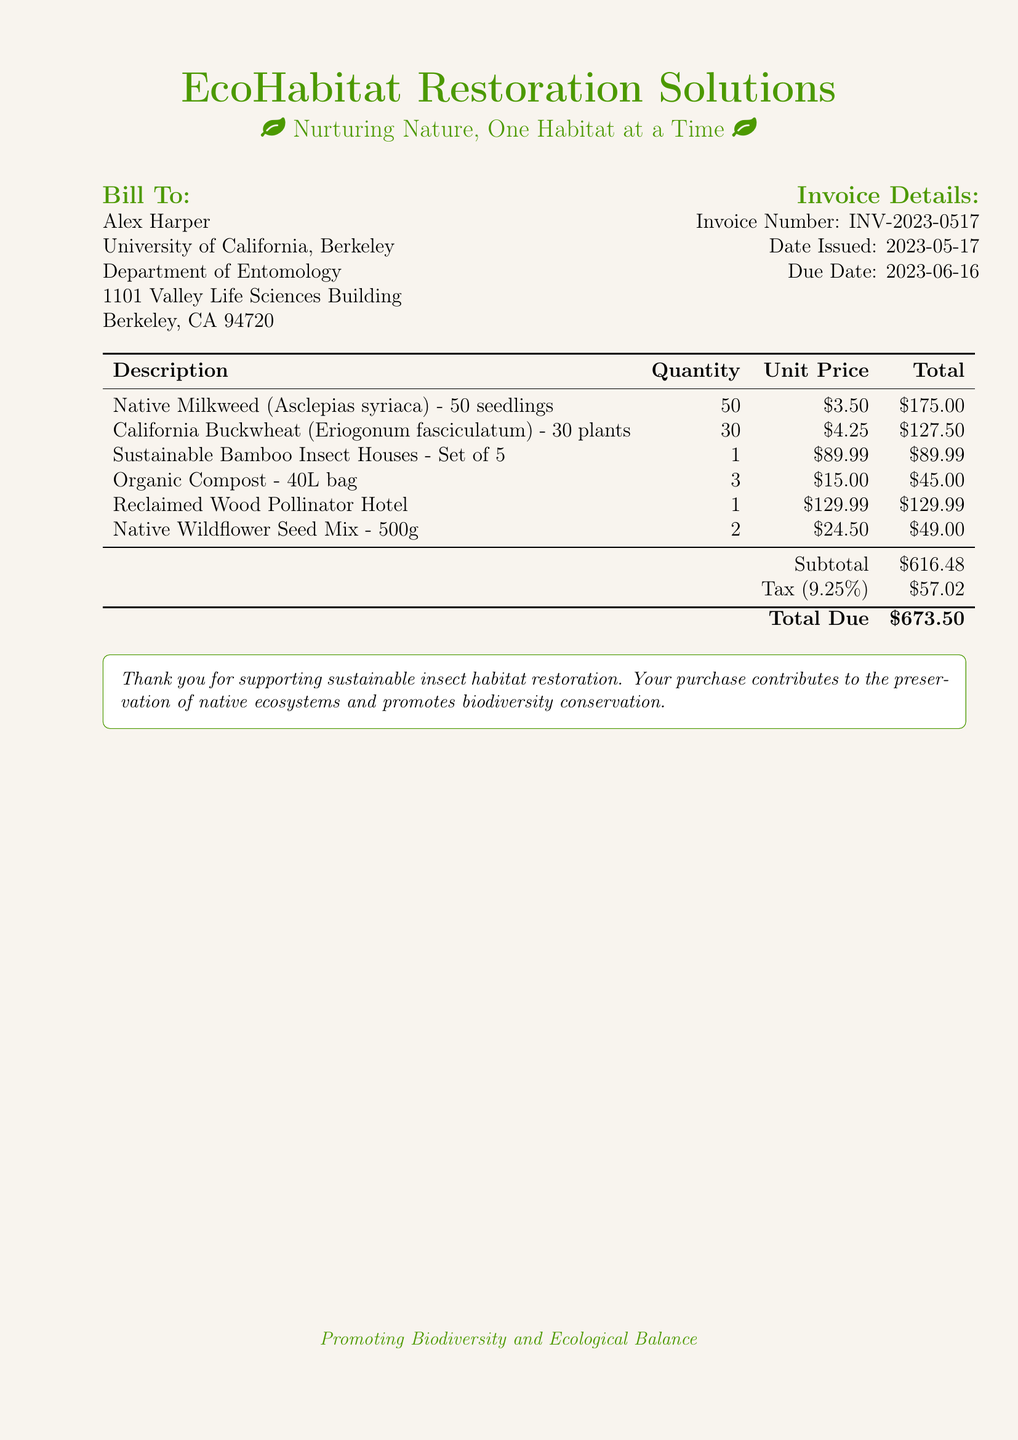What is the invoice number? The invoice number is found in the invoice details section.
Answer: INV-2023-0517 Who is the bill sent to? The recipient of the bill is listed under the "Bill To" section.
Answer: Alex Harper What is the total due amount? The total due is provided at the bottom of the table listing the charges.
Answer: $673.50 How many seedlings of Native Milkweed are included? The quantity of Native Milkweed seedlings is listed in the description of the item.
Answer: 50 What is the tax percentage applied to the subtotal? The tax percentage is mentioned in the tax row of the table.
Answer: 9.25% What type of natural materials are included in the invoice? The invoice lists types of materials, requiring a look through the descriptions to identify natural ones.
Answer: Organic Compost, Reclaimed Wood Pollinator Hotel What date was the invoice issued? The date issued is found in the invoice details section.
Answer: 2023-05-17 How many California Buckwheat plants are ordered? The quantity of California Buckwheat plants is specified in the item description.
Answer: 30 What is the unit price of the Sustainable Bamboo Insect Houses? The unit price is found next to the description of the Sustainable Bamboo Insect Houses.
Answer: $89.99 